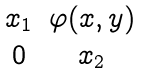<formula> <loc_0><loc_0><loc_500><loc_500>\begin{matrix} x _ { 1 } & \varphi ( x , y ) \\ 0 & x _ { 2 } \end{matrix}</formula> 